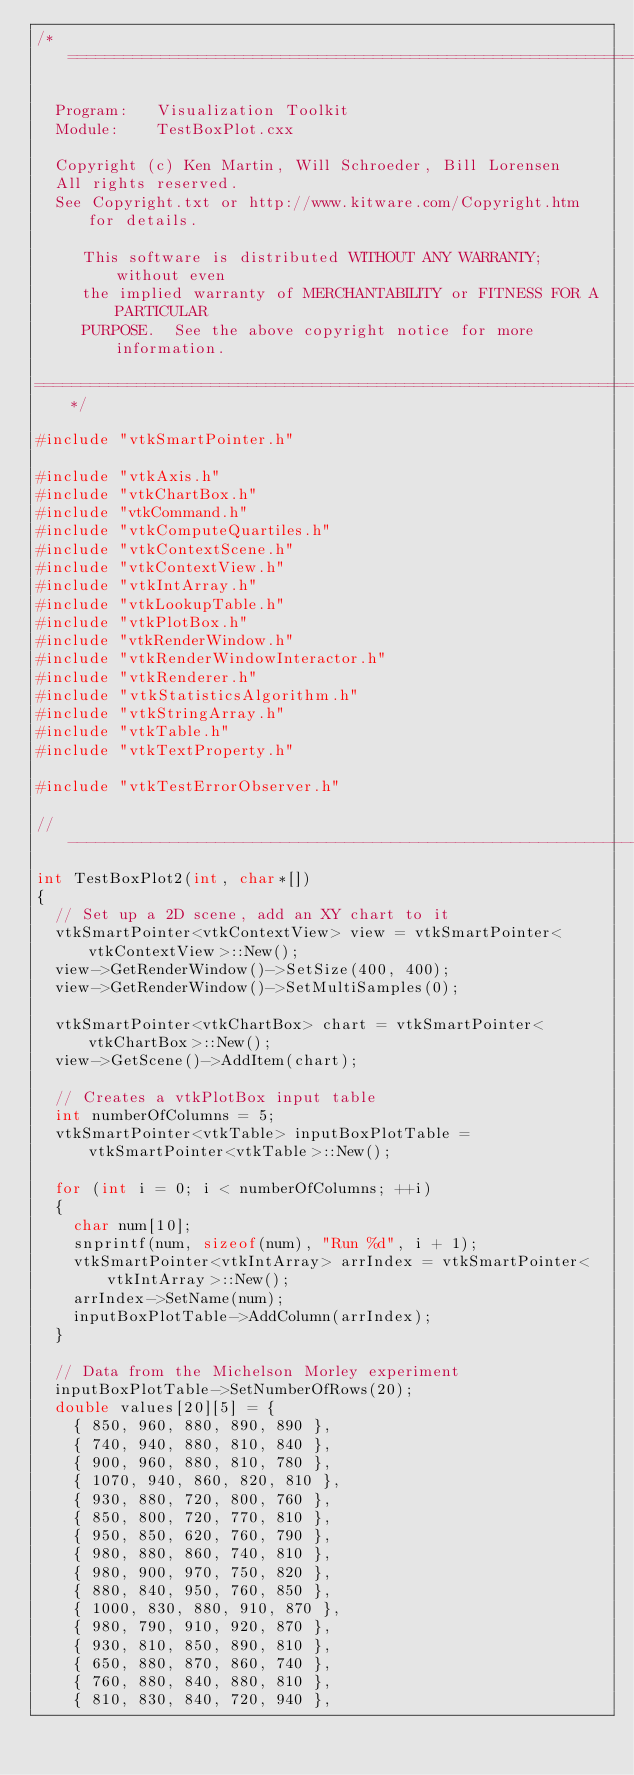Convert code to text. <code><loc_0><loc_0><loc_500><loc_500><_C++_>/*=========================================================================

  Program:   Visualization Toolkit
  Module:    TestBoxPlot.cxx

  Copyright (c) Ken Martin, Will Schroeder, Bill Lorensen
  All rights reserved.
  See Copyright.txt or http://www.kitware.com/Copyright.htm for details.

     This software is distributed WITHOUT ANY WARRANTY; without even
     the implied warranty of MERCHANTABILITY or FITNESS FOR A PARTICULAR
     PURPOSE.  See the above copyright notice for more information.

=========================================================================*/

#include "vtkSmartPointer.h"

#include "vtkAxis.h"
#include "vtkChartBox.h"
#include "vtkCommand.h"
#include "vtkComputeQuartiles.h"
#include "vtkContextScene.h"
#include "vtkContextView.h"
#include "vtkIntArray.h"
#include "vtkLookupTable.h"
#include "vtkPlotBox.h"
#include "vtkRenderWindow.h"
#include "vtkRenderWindowInteractor.h"
#include "vtkRenderer.h"
#include "vtkStatisticsAlgorithm.h"
#include "vtkStringArray.h"
#include "vtkTable.h"
#include "vtkTextProperty.h"

#include "vtkTestErrorObserver.h"

//----------------------------------------------------------------------------
int TestBoxPlot2(int, char*[])
{
  // Set up a 2D scene, add an XY chart to it
  vtkSmartPointer<vtkContextView> view = vtkSmartPointer<vtkContextView>::New();
  view->GetRenderWindow()->SetSize(400, 400);
  view->GetRenderWindow()->SetMultiSamples(0);

  vtkSmartPointer<vtkChartBox> chart = vtkSmartPointer<vtkChartBox>::New();
  view->GetScene()->AddItem(chart);

  // Creates a vtkPlotBox input table
  int numberOfColumns = 5;
  vtkSmartPointer<vtkTable> inputBoxPlotTable = vtkSmartPointer<vtkTable>::New();

  for (int i = 0; i < numberOfColumns; ++i)
  {
    char num[10];
    snprintf(num, sizeof(num), "Run %d", i + 1);
    vtkSmartPointer<vtkIntArray> arrIndex = vtkSmartPointer<vtkIntArray>::New();
    arrIndex->SetName(num);
    inputBoxPlotTable->AddColumn(arrIndex);
  }

  // Data from the Michelson Morley experiment
  inputBoxPlotTable->SetNumberOfRows(20);
  double values[20][5] = {
    { 850, 960, 880, 890, 890 },
    { 740, 940, 880, 810, 840 },
    { 900, 960, 880, 810, 780 },
    { 1070, 940, 860, 820, 810 },
    { 930, 880, 720, 800, 760 },
    { 850, 800, 720, 770, 810 },
    { 950, 850, 620, 760, 790 },
    { 980, 880, 860, 740, 810 },
    { 980, 900, 970, 750, 820 },
    { 880, 840, 950, 760, 850 },
    { 1000, 830, 880, 910, 870 },
    { 980, 790, 910, 920, 870 },
    { 930, 810, 850, 890, 810 },
    { 650, 880, 870, 860, 740 },
    { 760, 880, 840, 880, 810 },
    { 810, 830, 840, 720, 940 },</code> 